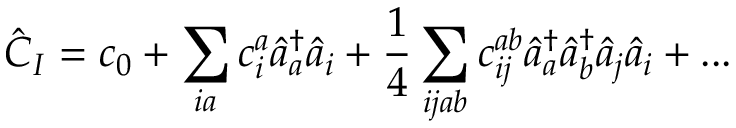<formula> <loc_0><loc_0><loc_500><loc_500>\hat { C } _ { I } = c _ { 0 } + \sum _ { i a } c _ { i } ^ { a } \hat { a } _ { a } ^ { \dagger } \hat { a } _ { i } + \frac { 1 } { 4 } \sum _ { i j a b } c _ { i j } ^ { a b } \hat { a } _ { a } ^ { \dagger } \hat { a } _ { b } ^ { \dagger } \hat { a } _ { j } \hat { a } _ { i } + \dots</formula> 